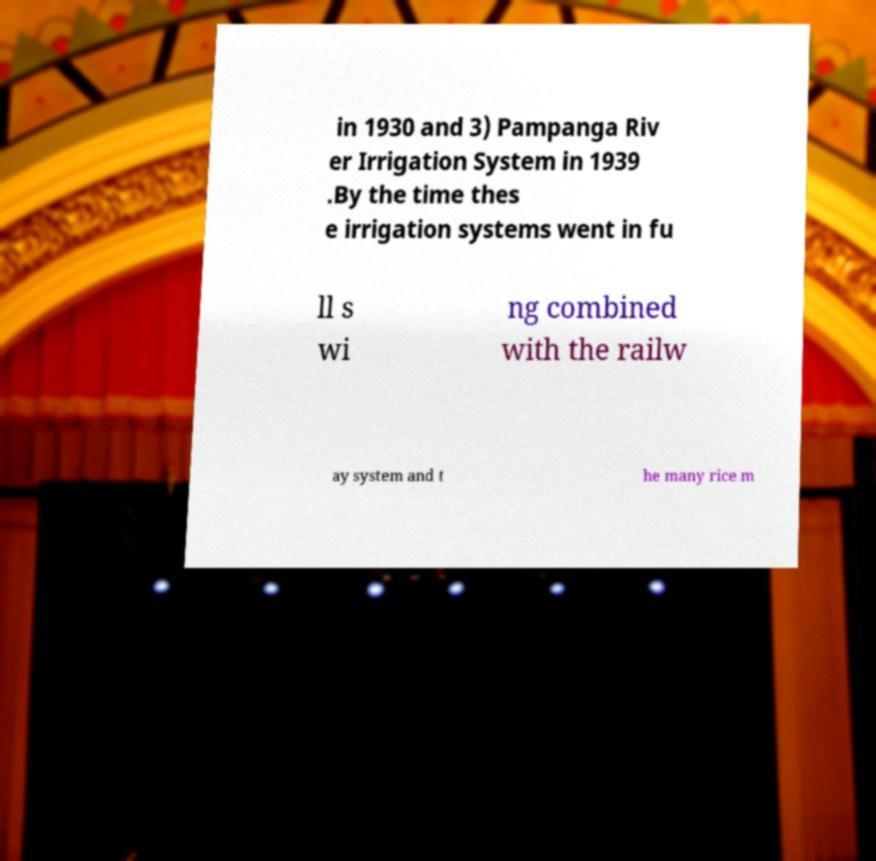I need the written content from this picture converted into text. Can you do that? in 1930 and 3) Pampanga Riv er Irrigation System in 1939 .By the time thes e irrigation systems went in fu ll s wi ng combined with the railw ay system and t he many rice m 